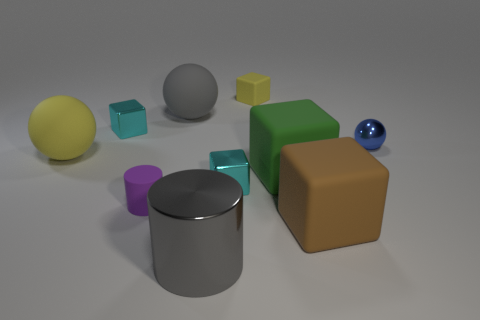Is there a large yellow object behind the big sphere that is in front of the big gray sphere?
Give a very brief answer. No. There is a rubber object on the right side of the green block; is it the same shape as the purple object?
Make the answer very short. No. The purple object has what shape?
Offer a terse response. Cylinder. What number of big gray things have the same material as the large cylinder?
Offer a terse response. 0. There is a large shiny cylinder; is its color the same as the matte ball that is on the right side of the tiny purple object?
Keep it short and to the point. Yes. What number of gray objects are there?
Give a very brief answer. 2. Are there any things that have the same color as the tiny matte block?
Give a very brief answer. Yes. What is the color of the cylinder that is behind the cylinder in front of the rubber block that is in front of the purple thing?
Provide a short and direct response. Purple. Are the small purple cylinder and the big sphere on the right side of the purple matte cylinder made of the same material?
Provide a short and direct response. Yes. What is the gray cylinder made of?
Provide a succinct answer. Metal. 